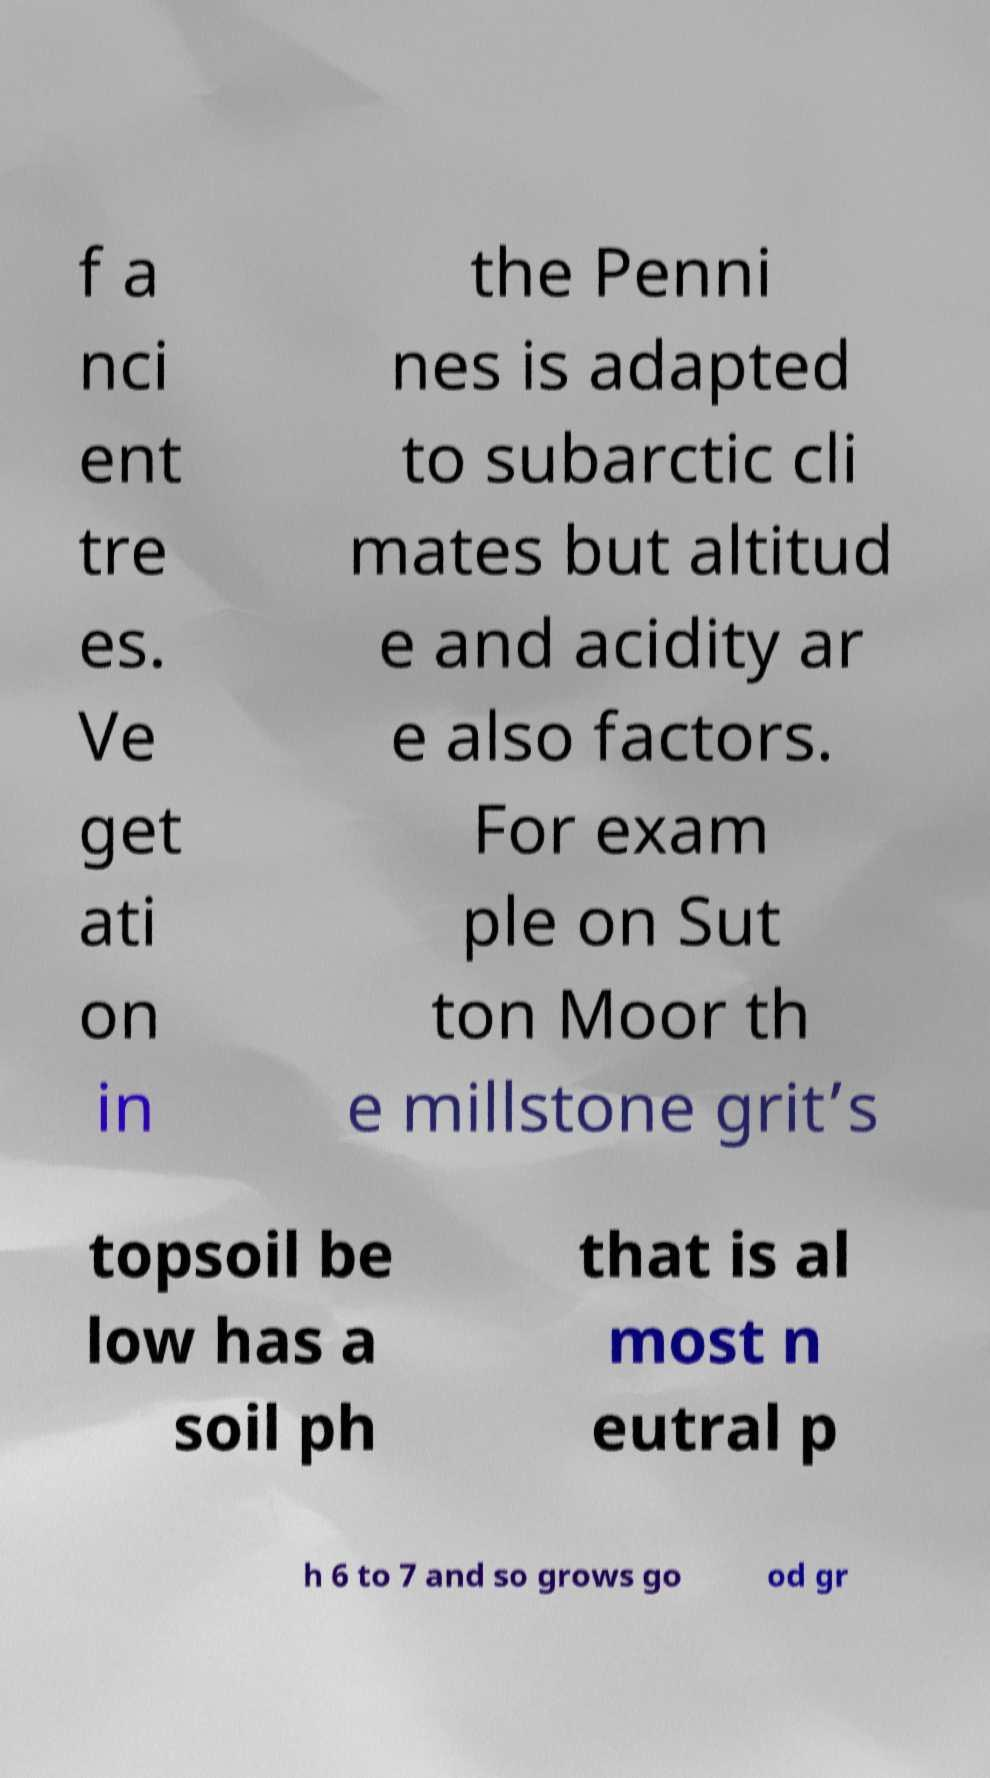Could you extract and type out the text from this image? f a nci ent tre es. Ve get ati on in the Penni nes is adapted to subarctic cli mates but altitud e and acidity ar e also factors. For exam ple on Sut ton Moor th e millstone grit’s topsoil be low has a soil ph that is al most n eutral p h 6 to 7 and so grows go od gr 